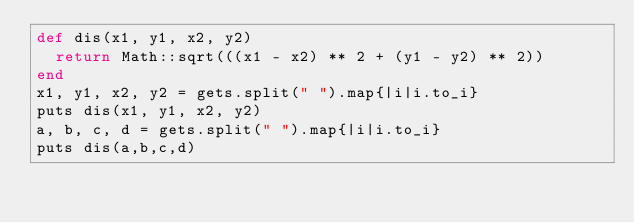Convert code to text. <code><loc_0><loc_0><loc_500><loc_500><_Ruby_>def dis(x1, y1, x2, y2)
  return Math::sqrt(((x1 - x2) ** 2 + (y1 - y2) ** 2))
end
x1, y1, x2, y2 = gets.split(" ").map{|i|i.to_i}
puts dis(x1, y1, x2, y2)
a, b, c, d = gets.split(" ").map{|i|i.to_i}
puts dis(a,b,c,d)</code> 